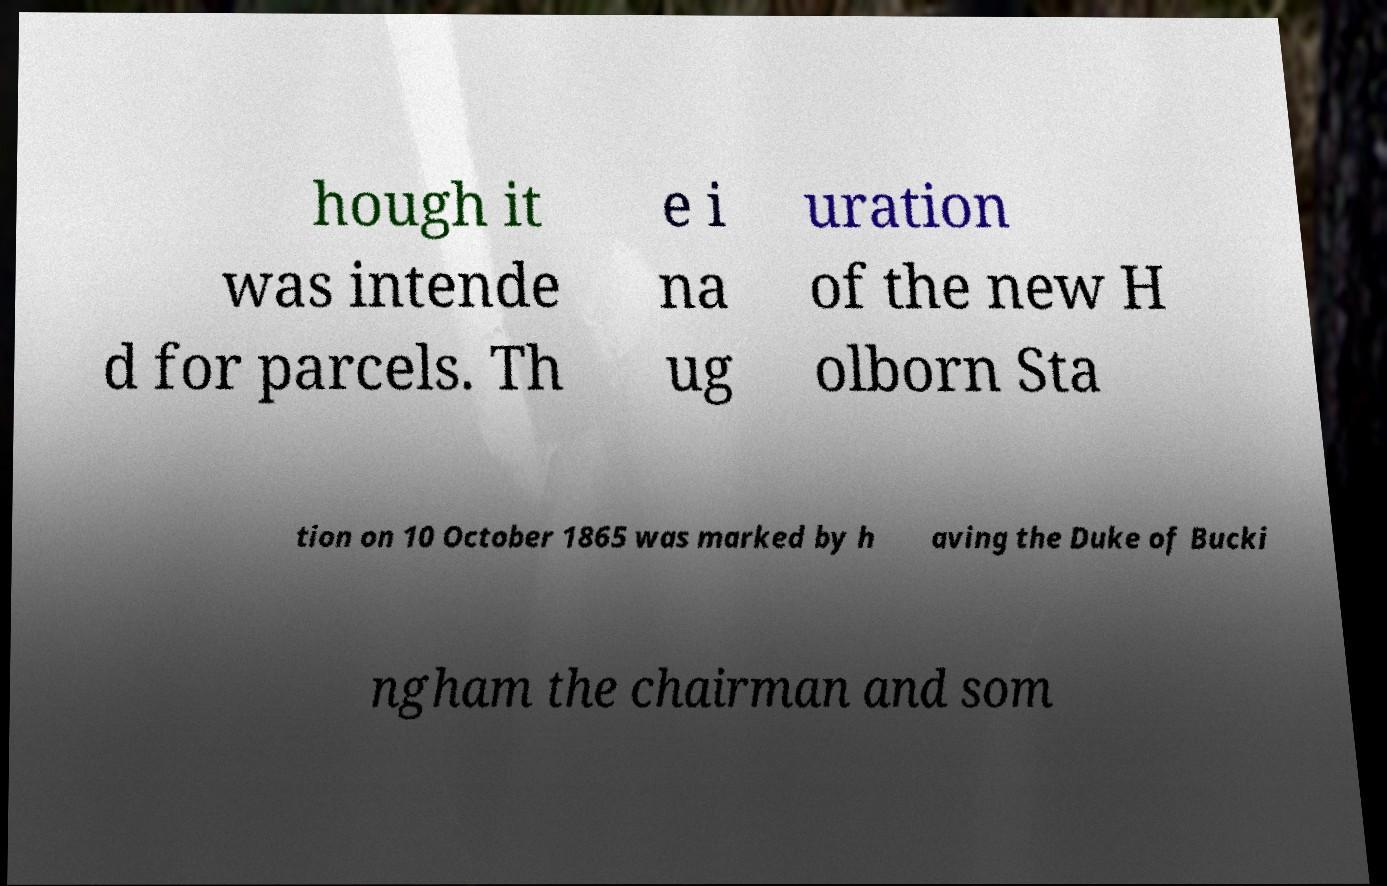There's text embedded in this image that I need extracted. Can you transcribe it verbatim? hough it was intende d for parcels. Th e i na ug uration of the new H olborn Sta tion on 10 October 1865 was marked by h aving the Duke of Bucki ngham the chairman and som 